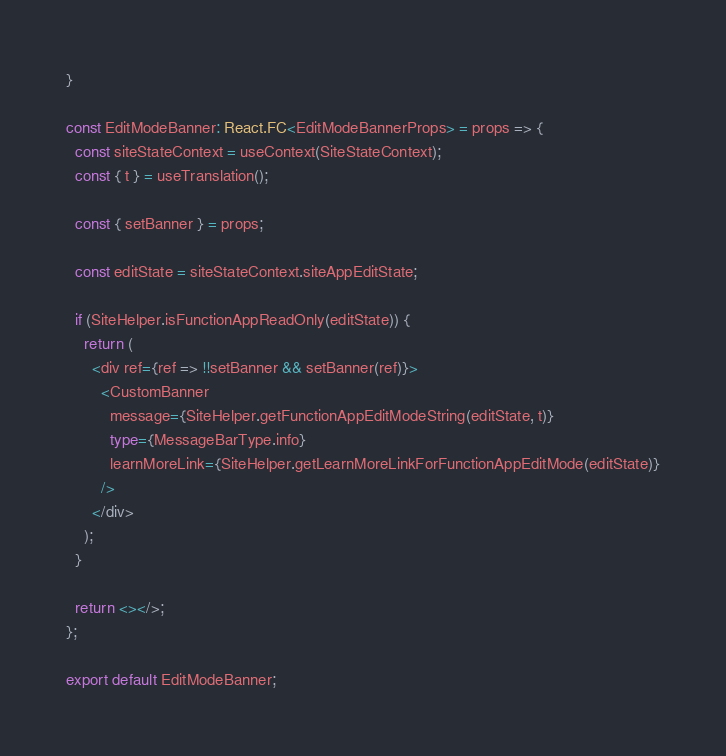Convert code to text. <code><loc_0><loc_0><loc_500><loc_500><_TypeScript_>}

const EditModeBanner: React.FC<EditModeBannerProps> = props => {
  const siteStateContext = useContext(SiteStateContext);
  const { t } = useTranslation();

  const { setBanner } = props;

  const editState = siteStateContext.siteAppEditState;

  if (SiteHelper.isFunctionAppReadOnly(editState)) {
    return (
      <div ref={ref => !!setBanner && setBanner(ref)}>
        <CustomBanner
          message={SiteHelper.getFunctionAppEditModeString(editState, t)}
          type={MessageBarType.info}
          learnMoreLink={SiteHelper.getLearnMoreLinkForFunctionAppEditMode(editState)}
        />
      </div>
    );
  }

  return <></>;
};

export default EditModeBanner;
</code> 